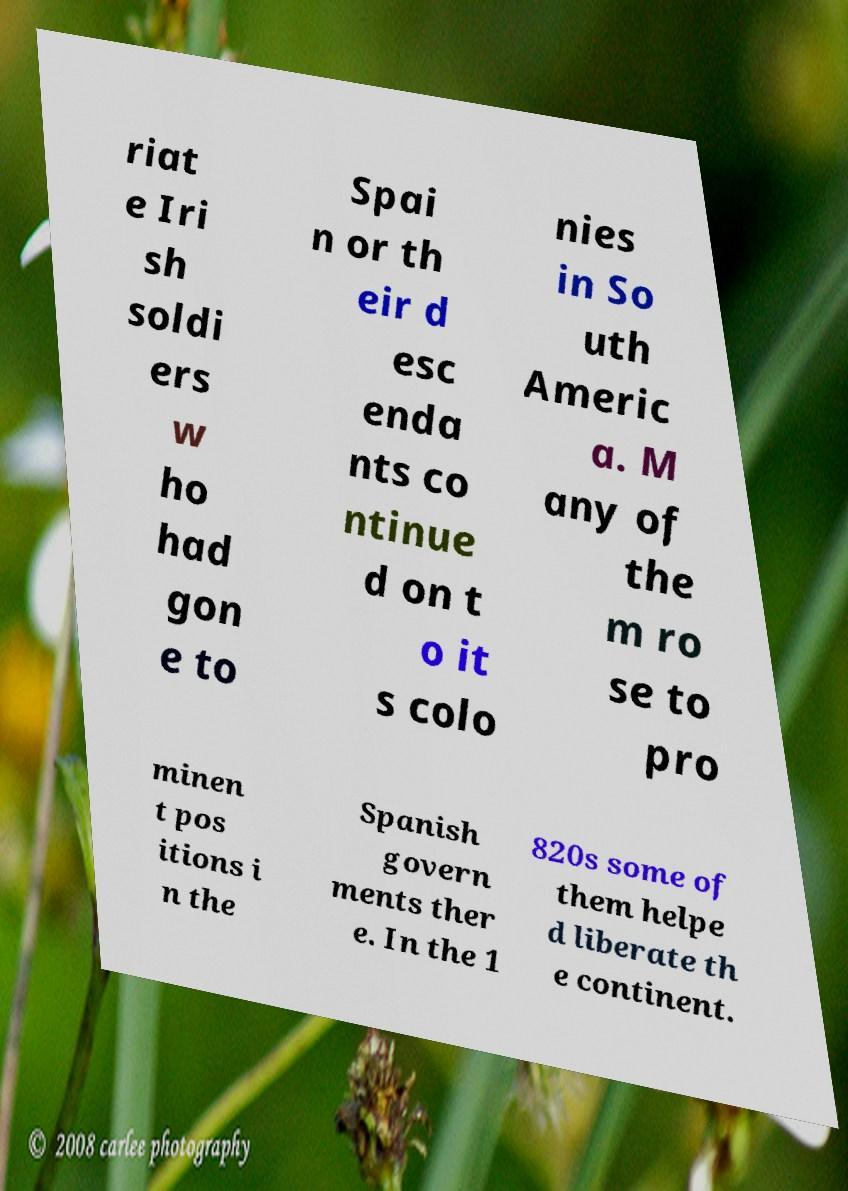There's text embedded in this image that I need extracted. Can you transcribe it verbatim? riat e Iri sh soldi ers w ho had gon e to Spai n or th eir d esc enda nts co ntinue d on t o it s colo nies in So uth Americ a. M any of the m ro se to pro minen t pos itions i n the Spanish govern ments ther e. In the 1 820s some of them helpe d liberate th e continent. 